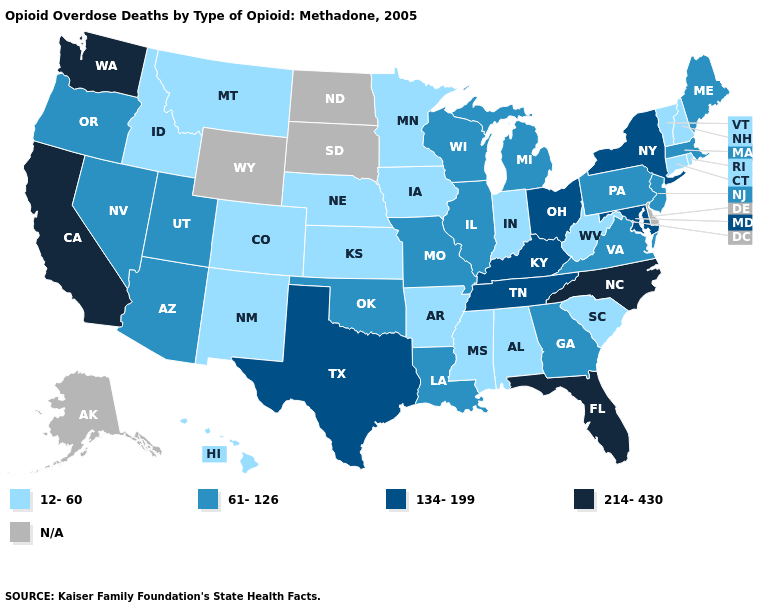Among the states that border Missouri , which have the highest value?
Be succinct. Kentucky, Tennessee. What is the value of West Virginia?
Write a very short answer. 12-60. Does Virginia have the lowest value in the South?
Keep it brief. No. What is the value of Alaska?
Quick response, please. N/A. Which states hav the highest value in the South?
Be succinct. Florida, North Carolina. Name the states that have a value in the range 61-126?
Write a very short answer. Arizona, Georgia, Illinois, Louisiana, Maine, Massachusetts, Michigan, Missouri, Nevada, New Jersey, Oklahoma, Oregon, Pennsylvania, Utah, Virginia, Wisconsin. What is the value of Hawaii?
Be succinct. 12-60. Among the states that border California , which have the lowest value?
Keep it brief. Arizona, Nevada, Oregon. Does the first symbol in the legend represent the smallest category?
Answer briefly. Yes. Which states have the lowest value in the USA?
Write a very short answer. Alabama, Arkansas, Colorado, Connecticut, Hawaii, Idaho, Indiana, Iowa, Kansas, Minnesota, Mississippi, Montana, Nebraska, New Hampshire, New Mexico, Rhode Island, South Carolina, Vermont, West Virginia. Does Washington have the highest value in the USA?
Be succinct. Yes. What is the highest value in the USA?
Concise answer only. 214-430. What is the value of South Carolina?
Write a very short answer. 12-60. Which states have the lowest value in the USA?
Write a very short answer. Alabama, Arkansas, Colorado, Connecticut, Hawaii, Idaho, Indiana, Iowa, Kansas, Minnesota, Mississippi, Montana, Nebraska, New Hampshire, New Mexico, Rhode Island, South Carolina, Vermont, West Virginia. 